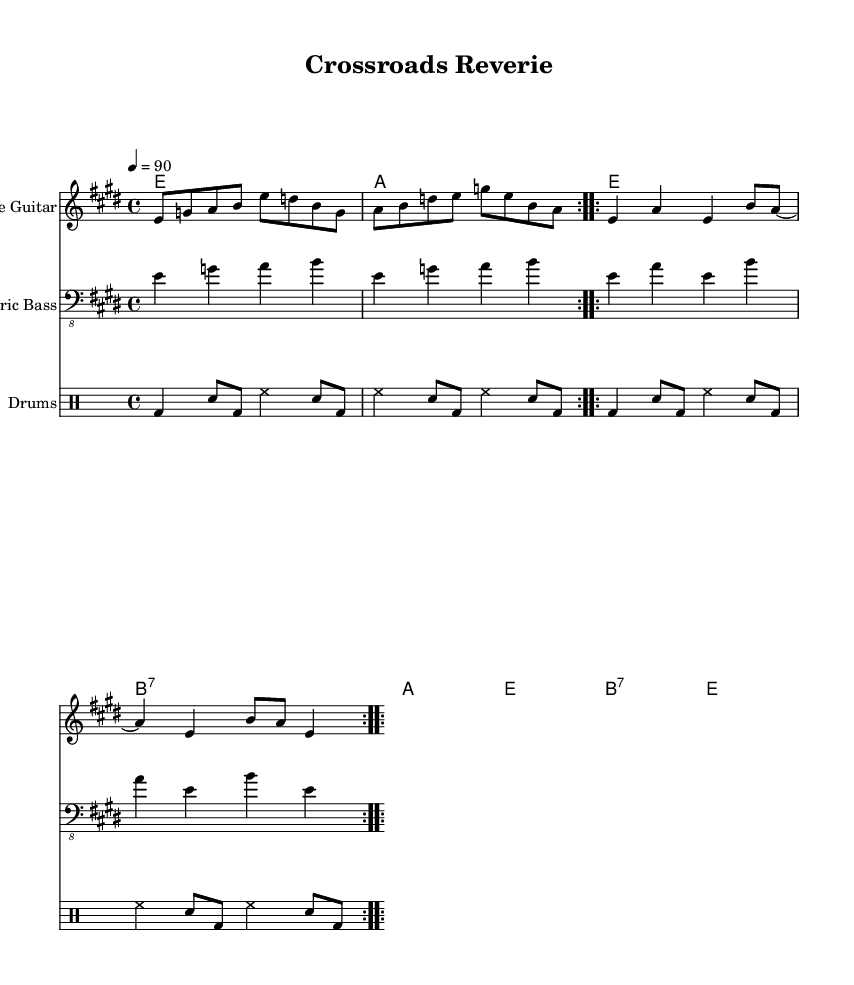What is the key signature of this music? The key signature is E major, which has four sharps.
Answer: E major What is the time signature of this piece? The time signature is 4/4, indicating four beats per measure.
Answer: 4/4 What is the tempo marking for this piece? The tempo marking is 90 beats per minute, as indicated by the number below the tempo text.
Answer: 90 How many measures are repeated in the slide guitar part? The slide guitar part contains two repeated sections, indicated by the repeat signs.
Answer: Two What is the primary chord progression outlined in the chord names? The primary chord progression outlines E, A, and B7 chords, which are commonly used in blues.
Answer: E, A, B7 What instrument is featured prominently in this composition? The featured instrument is the slide guitar, as indicated in the staff heading.
Answer: Slide guitar What rhythmic pattern is indicated for the drums? The drums part includes a basic pattern that alternates between bass drum, snare, and hi-hat, creating a standard driving beat.
Answer: Alternating bass, snare, hi-hat 